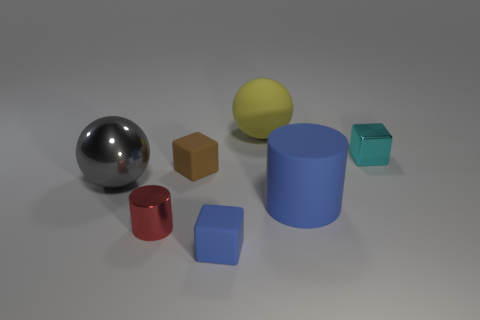The tiny red metallic object is what shape?
Your answer should be very brief. Cylinder. There is a rubber object in front of the blue matte cylinder; what is its size?
Your answer should be very brief. Small. There is a metal object that is the same size as the metallic cube; what is its color?
Offer a terse response. Red. Is there a ball of the same color as the tiny metallic block?
Your answer should be very brief. No. Are there fewer brown matte things on the right side of the small brown rubber cube than small brown blocks that are to the right of the cyan metal cube?
Give a very brief answer. No. What material is the block that is both behind the tiny metal cylinder and left of the large yellow matte thing?
Ensure brevity in your answer.  Rubber. Is the shape of the tiny brown thing the same as the large object in front of the big gray metallic thing?
Make the answer very short. No. What number of other objects are there of the same size as the shiny cylinder?
Offer a very short reply. 3. Is the number of small metallic cylinders greater than the number of small purple objects?
Provide a succinct answer. Yes. How many blue rubber objects are behind the blue block and on the left side of the yellow rubber object?
Offer a terse response. 0. 